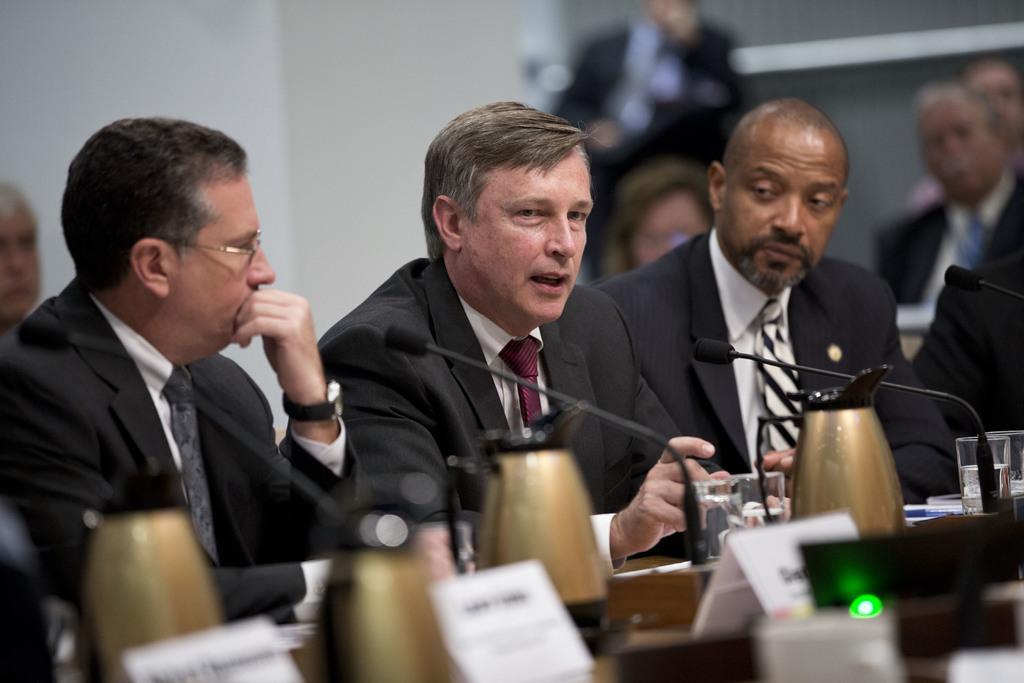In one or two sentences, can you explain what this image depicts? In this image I can see the group of people sitting and wearing the blazers. These people are in-front of the table. On the table I can see the boards, glasses and mics. And there is a blurred background. 